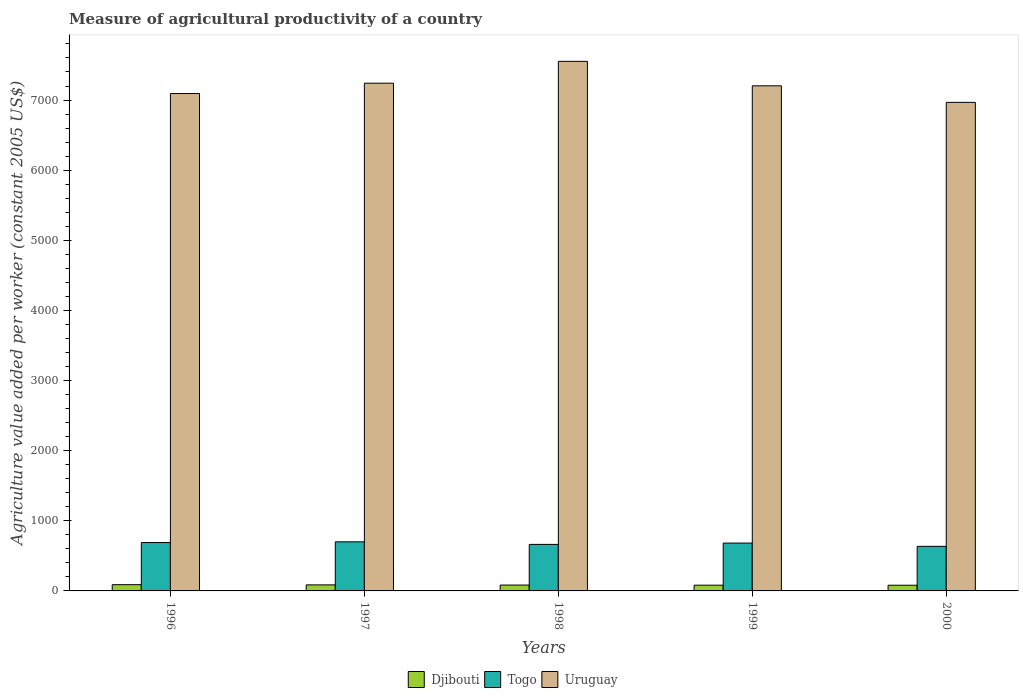How many groups of bars are there?
Offer a very short reply. 5. Are the number of bars per tick equal to the number of legend labels?
Offer a terse response. Yes. What is the measure of agricultural productivity in Togo in 1998?
Give a very brief answer. 663.32. Across all years, what is the maximum measure of agricultural productivity in Togo?
Make the answer very short. 700.08. Across all years, what is the minimum measure of agricultural productivity in Djibouti?
Offer a very short reply. 81.3. In which year was the measure of agricultural productivity in Djibouti maximum?
Your answer should be compact. 1996. In which year was the measure of agricultural productivity in Uruguay minimum?
Your answer should be very brief. 2000. What is the total measure of agricultural productivity in Togo in the graph?
Make the answer very short. 3371.1. What is the difference between the measure of agricultural productivity in Djibouti in 1999 and that in 2000?
Offer a very short reply. 0.63. What is the difference between the measure of agricultural productivity in Uruguay in 2000 and the measure of agricultural productivity in Togo in 1997?
Your answer should be compact. 6266.63. What is the average measure of agricultural productivity in Togo per year?
Keep it short and to the point. 674.22. In the year 2000, what is the difference between the measure of agricultural productivity in Togo and measure of agricultural productivity in Djibouti?
Offer a terse response. 554.53. What is the ratio of the measure of agricultural productivity in Uruguay in 1996 to that in 1998?
Your answer should be compact. 0.94. Is the difference between the measure of agricultural productivity in Togo in 1998 and 1999 greater than the difference between the measure of agricultural productivity in Djibouti in 1998 and 1999?
Provide a succinct answer. No. What is the difference between the highest and the second highest measure of agricultural productivity in Uruguay?
Keep it short and to the point. 311.42. What is the difference between the highest and the lowest measure of agricultural productivity in Djibouti?
Your response must be concise. 7.74. What does the 2nd bar from the left in 1997 represents?
Your answer should be very brief. Togo. What does the 2nd bar from the right in 1996 represents?
Your answer should be very brief. Togo. Is it the case that in every year, the sum of the measure of agricultural productivity in Uruguay and measure of agricultural productivity in Togo is greater than the measure of agricultural productivity in Djibouti?
Make the answer very short. Yes. How many years are there in the graph?
Give a very brief answer. 5. Are the values on the major ticks of Y-axis written in scientific E-notation?
Provide a succinct answer. No. Does the graph contain any zero values?
Offer a very short reply. No. How many legend labels are there?
Provide a succinct answer. 3. How are the legend labels stacked?
Keep it short and to the point. Horizontal. What is the title of the graph?
Ensure brevity in your answer.  Measure of agricultural productivity of a country. What is the label or title of the X-axis?
Provide a short and direct response. Years. What is the label or title of the Y-axis?
Provide a succinct answer. Agriculture value added per worker (constant 2005 US$). What is the Agriculture value added per worker (constant 2005 US$) in Djibouti in 1996?
Your answer should be very brief. 89.04. What is the Agriculture value added per worker (constant 2005 US$) in Togo in 1996?
Offer a terse response. 689.62. What is the Agriculture value added per worker (constant 2005 US$) in Uruguay in 1996?
Offer a very short reply. 7092.6. What is the Agriculture value added per worker (constant 2005 US$) in Djibouti in 1997?
Your answer should be very brief. 86.22. What is the Agriculture value added per worker (constant 2005 US$) of Togo in 1997?
Ensure brevity in your answer.  700.08. What is the Agriculture value added per worker (constant 2005 US$) in Uruguay in 1997?
Your answer should be compact. 7240.05. What is the Agriculture value added per worker (constant 2005 US$) in Djibouti in 1998?
Keep it short and to the point. 83.72. What is the Agriculture value added per worker (constant 2005 US$) of Togo in 1998?
Make the answer very short. 663.32. What is the Agriculture value added per worker (constant 2005 US$) of Uruguay in 1998?
Provide a succinct answer. 7551.47. What is the Agriculture value added per worker (constant 2005 US$) of Djibouti in 1999?
Give a very brief answer. 81.93. What is the Agriculture value added per worker (constant 2005 US$) of Togo in 1999?
Keep it short and to the point. 682.25. What is the Agriculture value added per worker (constant 2005 US$) of Uruguay in 1999?
Your answer should be compact. 7202.62. What is the Agriculture value added per worker (constant 2005 US$) in Djibouti in 2000?
Offer a terse response. 81.3. What is the Agriculture value added per worker (constant 2005 US$) of Togo in 2000?
Provide a succinct answer. 635.84. What is the Agriculture value added per worker (constant 2005 US$) of Uruguay in 2000?
Your answer should be very brief. 6966.71. Across all years, what is the maximum Agriculture value added per worker (constant 2005 US$) in Djibouti?
Offer a terse response. 89.04. Across all years, what is the maximum Agriculture value added per worker (constant 2005 US$) of Togo?
Provide a short and direct response. 700.08. Across all years, what is the maximum Agriculture value added per worker (constant 2005 US$) of Uruguay?
Make the answer very short. 7551.47. Across all years, what is the minimum Agriculture value added per worker (constant 2005 US$) in Djibouti?
Provide a short and direct response. 81.3. Across all years, what is the minimum Agriculture value added per worker (constant 2005 US$) in Togo?
Offer a very short reply. 635.84. Across all years, what is the minimum Agriculture value added per worker (constant 2005 US$) of Uruguay?
Provide a succinct answer. 6966.71. What is the total Agriculture value added per worker (constant 2005 US$) of Djibouti in the graph?
Make the answer very short. 422.21. What is the total Agriculture value added per worker (constant 2005 US$) of Togo in the graph?
Provide a short and direct response. 3371.1. What is the total Agriculture value added per worker (constant 2005 US$) of Uruguay in the graph?
Keep it short and to the point. 3.61e+04. What is the difference between the Agriculture value added per worker (constant 2005 US$) of Djibouti in 1996 and that in 1997?
Your answer should be compact. 2.82. What is the difference between the Agriculture value added per worker (constant 2005 US$) in Togo in 1996 and that in 1997?
Your answer should be compact. -10.46. What is the difference between the Agriculture value added per worker (constant 2005 US$) of Uruguay in 1996 and that in 1997?
Give a very brief answer. -147.45. What is the difference between the Agriculture value added per worker (constant 2005 US$) of Djibouti in 1996 and that in 1998?
Offer a terse response. 5.32. What is the difference between the Agriculture value added per worker (constant 2005 US$) of Togo in 1996 and that in 1998?
Offer a very short reply. 26.29. What is the difference between the Agriculture value added per worker (constant 2005 US$) of Uruguay in 1996 and that in 1998?
Ensure brevity in your answer.  -458.87. What is the difference between the Agriculture value added per worker (constant 2005 US$) of Djibouti in 1996 and that in 1999?
Offer a terse response. 7.11. What is the difference between the Agriculture value added per worker (constant 2005 US$) in Togo in 1996 and that in 1999?
Make the answer very short. 7.37. What is the difference between the Agriculture value added per worker (constant 2005 US$) in Uruguay in 1996 and that in 1999?
Offer a very short reply. -110.02. What is the difference between the Agriculture value added per worker (constant 2005 US$) in Djibouti in 1996 and that in 2000?
Provide a succinct answer. 7.74. What is the difference between the Agriculture value added per worker (constant 2005 US$) in Togo in 1996 and that in 2000?
Keep it short and to the point. 53.78. What is the difference between the Agriculture value added per worker (constant 2005 US$) of Uruguay in 1996 and that in 2000?
Offer a terse response. 125.89. What is the difference between the Agriculture value added per worker (constant 2005 US$) in Djibouti in 1997 and that in 1998?
Your answer should be very brief. 2.49. What is the difference between the Agriculture value added per worker (constant 2005 US$) in Togo in 1997 and that in 1998?
Give a very brief answer. 36.75. What is the difference between the Agriculture value added per worker (constant 2005 US$) of Uruguay in 1997 and that in 1998?
Ensure brevity in your answer.  -311.42. What is the difference between the Agriculture value added per worker (constant 2005 US$) of Djibouti in 1997 and that in 1999?
Keep it short and to the point. 4.29. What is the difference between the Agriculture value added per worker (constant 2005 US$) in Togo in 1997 and that in 1999?
Your response must be concise. 17.83. What is the difference between the Agriculture value added per worker (constant 2005 US$) of Uruguay in 1997 and that in 1999?
Provide a short and direct response. 37.42. What is the difference between the Agriculture value added per worker (constant 2005 US$) in Djibouti in 1997 and that in 2000?
Ensure brevity in your answer.  4.91. What is the difference between the Agriculture value added per worker (constant 2005 US$) in Togo in 1997 and that in 2000?
Offer a terse response. 64.24. What is the difference between the Agriculture value added per worker (constant 2005 US$) in Uruguay in 1997 and that in 2000?
Your answer should be compact. 273.34. What is the difference between the Agriculture value added per worker (constant 2005 US$) of Djibouti in 1998 and that in 1999?
Ensure brevity in your answer.  1.79. What is the difference between the Agriculture value added per worker (constant 2005 US$) of Togo in 1998 and that in 1999?
Offer a very short reply. -18.92. What is the difference between the Agriculture value added per worker (constant 2005 US$) in Uruguay in 1998 and that in 1999?
Provide a succinct answer. 348.85. What is the difference between the Agriculture value added per worker (constant 2005 US$) of Djibouti in 1998 and that in 2000?
Provide a short and direct response. 2.42. What is the difference between the Agriculture value added per worker (constant 2005 US$) in Togo in 1998 and that in 2000?
Provide a short and direct response. 27.49. What is the difference between the Agriculture value added per worker (constant 2005 US$) of Uruguay in 1998 and that in 2000?
Your answer should be compact. 584.76. What is the difference between the Agriculture value added per worker (constant 2005 US$) of Djibouti in 1999 and that in 2000?
Give a very brief answer. 0.63. What is the difference between the Agriculture value added per worker (constant 2005 US$) in Togo in 1999 and that in 2000?
Keep it short and to the point. 46.41. What is the difference between the Agriculture value added per worker (constant 2005 US$) in Uruguay in 1999 and that in 2000?
Give a very brief answer. 235.91. What is the difference between the Agriculture value added per worker (constant 2005 US$) of Djibouti in 1996 and the Agriculture value added per worker (constant 2005 US$) of Togo in 1997?
Ensure brevity in your answer.  -611.04. What is the difference between the Agriculture value added per worker (constant 2005 US$) in Djibouti in 1996 and the Agriculture value added per worker (constant 2005 US$) in Uruguay in 1997?
Keep it short and to the point. -7151.01. What is the difference between the Agriculture value added per worker (constant 2005 US$) of Togo in 1996 and the Agriculture value added per worker (constant 2005 US$) of Uruguay in 1997?
Keep it short and to the point. -6550.43. What is the difference between the Agriculture value added per worker (constant 2005 US$) of Djibouti in 1996 and the Agriculture value added per worker (constant 2005 US$) of Togo in 1998?
Give a very brief answer. -574.29. What is the difference between the Agriculture value added per worker (constant 2005 US$) of Djibouti in 1996 and the Agriculture value added per worker (constant 2005 US$) of Uruguay in 1998?
Provide a short and direct response. -7462.43. What is the difference between the Agriculture value added per worker (constant 2005 US$) in Togo in 1996 and the Agriculture value added per worker (constant 2005 US$) in Uruguay in 1998?
Give a very brief answer. -6861.85. What is the difference between the Agriculture value added per worker (constant 2005 US$) in Djibouti in 1996 and the Agriculture value added per worker (constant 2005 US$) in Togo in 1999?
Your answer should be very brief. -593.21. What is the difference between the Agriculture value added per worker (constant 2005 US$) in Djibouti in 1996 and the Agriculture value added per worker (constant 2005 US$) in Uruguay in 1999?
Offer a very short reply. -7113.58. What is the difference between the Agriculture value added per worker (constant 2005 US$) in Togo in 1996 and the Agriculture value added per worker (constant 2005 US$) in Uruguay in 1999?
Provide a succinct answer. -6513. What is the difference between the Agriculture value added per worker (constant 2005 US$) in Djibouti in 1996 and the Agriculture value added per worker (constant 2005 US$) in Togo in 2000?
Offer a very short reply. -546.8. What is the difference between the Agriculture value added per worker (constant 2005 US$) of Djibouti in 1996 and the Agriculture value added per worker (constant 2005 US$) of Uruguay in 2000?
Keep it short and to the point. -6877.67. What is the difference between the Agriculture value added per worker (constant 2005 US$) of Togo in 1996 and the Agriculture value added per worker (constant 2005 US$) of Uruguay in 2000?
Your response must be concise. -6277.09. What is the difference between the Agriculture value added per worker (constant 2005 US$) in Djibouti in 1997 and the Agriculture value added per worker (constant 2005 US$) in Togo in 1998?
Give a very brief answer. -577.11. What is the difference between the Agriculture value added per worker (constant 2005 US$) of Djibouti in 1997 and the Agriculture value added per worker (constant 2005 US$) of Uruguay in 1998?
Provide a succinct answer. -7465.25. What is the difference between the Agriculture value added per worker (constant 2005 US$) of Togo in 1997 and the Agriculture value added per worker (constant 2005 US$) of Uruguay in 1998?
Ensure brevity in your answer.  -6851.39. What is the difference between the Agriculture value added per worker (constant 2005 US$) in Djibouti in 1997 and the Agriculture value added per worker (constant 2005 US$) in Togo in 1999?
Provide a succinct answer. -596.03. What is the difference between the Agriculture value added per worker (constant 2005 US$) in Djibouti in 1997 and the Agriculture value added per worker (constant 2005 US$) in Uruguay in 1999?
Ensure brevity in your answer.  -7116.4. What is the difference between the Agriculture value added per worker (constant 2005 US$) in Togo in 1997 and the Agriculture value added per worker (constant 2005 US$) in Uruguay in 1999?
Your response must be concise. -6502.55. What is the difference between the Agriculture value added per worker (constant 2005 US$) of Djibouti in 1997 and the Agriculture value added per worker (constant 2005 US$) of Togo in 2000?
Make the answer very short. -549.62. What is the difference between the Agriculture value added per worker (constant 2005 US$) in Djibouti in 1997 and the Agriculture value added per worker (constant 2005 US$) in Uruguay in 2000?
Your answer should be compact. -6880.49. What is the difference between the Agriculture value added per worker (constant 2005 US$) of Togo in 1997 and the Agriculture value added per worker (constant 2005 US$) of Uruguay in 2000?
Give a very brief answer. -6266.63. What is the difference between the Agriculture value added per worker (constant 2005 US$) of Djibouti in 1998 and the Agriculture value added per worker (constant 2005 US$) of Togo in 1999?
Offer a terse response. -598.52. What is the difference between the Agriculture value added per worker (constant 2005 US$) in Djibouti in 1998 and the Agriculture value added per worker (constant 2005 US$) in Uruguay in 1999?
Keep it short and to the point. -7118.9. What is the difference between the Agriculture value added per worker (constant 2005 US$) in Togo in 1998 and the Agriculture value added per worker (constant 2005 US$) in Uruguay in 1999?
Provide a succinct answer. -6539.3. What is the difference between the Agriculture value added per worker (constant 2005 US$) in Djibouti in 1998 and the Agriculture value added per worker (constant 2005 US$) in Togo in 2000?
Provide a short and direct response. -552.11. What is the difference between the Agriculture value added per worker (constant 2005 US$) of Djibouti in 1998 and the Agriculture value added per worker (constant 2005 US$) of Uruguay in 2000?
Give a very brief answer. -6882.99. What is the difference between the Agriculture value added per worker (constant 2005 US$) of Togo in 1998 and the Agriculture value added per worker (constant 2005 US$) of Uruguay in 2000?
Offer a terse response. -6303.39. What is the difference between the Agriculture value added per worker (constant 2005 US$) of Djibouti in 1999 and the Agriculture value added per worker (constant 2005 US$) of Togo in 2000?
Provide a short and direct response. -553.91. What is the difference between the Agriculture value added per worker (constant 2005 US$) of Djibouti in 1999 and the Agriculture value added per worker (constant 2005 US$) of Uruguay in 2000?
Your answer should be compact. -6884.78. What is the difference between the Agriculture value added per worker (constant 2005 US$) of Togo in 1999 and the Agriculture value added per worker (constant 2005 US$) of Uruguay in 2000?
Your answer should be very brief. -6284.46. What is the average Agriculture value added per worker (constant 2005 US$) of Djibouti per year?
Make the answer very short. 84.44. What is the average Agriculture value added per worker (constant 2005 US$) of Togo per year?
Your answer should be very brief. 674.22. What is the average Agriculture value added per worker (constant 2005 US$) in Uruguay per year?
Give a very brief answer. 7210.69. In the year 1996, what is the difference between the Agriculture value added per worker (constant 2005 US$) of Djibouti and Agriculture value added per worker (constant 2005 US$) of Togo?
Provide a succinct answer. -600.58. In the year 1996, what is the difference between the Agriculture value added per worker (constant 2005 US$) of Djibouti and Agriculture value added per worker (constant 2005 US$) of Uruguay?
Provide a succinct answer. -7003.56. In the year 1996, what is the difference between the Agriculture value added per worker (constant 2005 US$) of Togo and Agriculture value added per worker (constant 2005 US$) of Uruguay?
Offer a very short reply. -6402.98. In the year 1997, what is the difference between the Agriculture value added per worker (constant 2005 US$) of Djibouti and Agriculture value added per worker (constant 2005 US$) of Togo?
Ensure brevity in your answer.  -613.86. In the year 1997, what is the difference between the Agriculture value added per worker (constant 2005 US$) of Djibouti and Agriculture value added per worker (constant 2005 US$) of Uruguay?
Offer a terse response. -7153.83. In the year 1997, what is the difference between the Agriculture value added per worker (constant 2005 US$) in Togo and Agriculture value added per worker (constant 2005 US$) in Uruguay?
Your response must be concise. -6539.97. In the year 1998, what is the difference between the Agriculture value added per worker (constant 2005 US$) in Djibouti and Agriculture value added per worker (constant 2005 US$) in Togo?
Provide a succinct answer. -579.6. In the year 1998, what is the difference between the Agriculture value added per worker (constant 2005 US$) in Djibouti and Agriculture value added per worker (constant 2005 US$) in Uruguay?
Offer a terse response. -7467.75. In the year 1998, what is the difference between the Agriculture value added per worker (constant 2005 US$) of Togo and Agriculture value added per worker (constant 2005 US$) of Uruguay?
Ensure brevity in your answer.  -6888.15. In the year 1999, what is the difference between the Agriculture value added per worker (constant 2005 US$) of Djibouti and Agriculture value added per worker (constant 2005 US$) of Togo?
Keep it short and to the point. -600.32. In the year 1999, what is the difference between the Agriculture value added per worker (constant 2005 US$) in Djibouti and Agriculture value added per worker (constant 2005 US$) in Uruguay?
Offer a terse response. -7120.69. In the year 1999, what is the difference between the Agriculture value added per worker (constant 2005 US$) in Togo and Agriculture value added per worker (constant 2005 US$) in Uruguay?
Ensure brevity in your answer.  -6520.38. In the year 2000, what is the difference between the Agriculture value added per worker (constant 2005 US$) in Djibouti and Agriculture value added per worker (constant 2005 US$) in Togo?
Make the answer very short. -554.53. In the year 2000, what is the difference between the Agriculture value added per worker (constant 2005 US$) of Djibouti and Agriculture value added per worker (constant 2005 US$) of Uruguay?
Ensure brevity in your answer.  -6885.41. In the year 2000, what is the difference between the Agriculture value added per worker (constant 2005 US$) of Togo and Agriculture value added per worker (constant 2005 US$) of Uruguay?
Offer a very short reply. -6330.87. What is the ratio of the Agriculture value added per worker (constant 2005 US$) of Djibouti in 1996 to that in 1997?
Make the answer very short. 1.03. What is the ratio of the Agriculture value added per worker (constant 2005 US$) in Togo in 1996 to that in 1997?
Keep it short and to the point. 0.99. What is the ratio of the Agriculture value added per worker (constant 2005 US$) in Uruguay in 1996 to that in 1997?
Your answer should be very brief. 0.98. What is the ratio of the Agriculture value added per worker (constant 2005 US$) in Djibouti in 1996 to that in 1998?
Keep it short and to the point. 1.06. What is the ratio of the Agriculture value added per worker (constant 2005 US$) of Togo in 1996 to that in 1998?
Make the answer very short. 1.04. What is the ratio of the Agriculture value added per worker (constant 2005 US$) of Uruguay in 1996 to that in 1998?
Offer a very short reply. 0.94. What is the ratio of the Agriculture value added per worker (constant 2005 US$) of Djibouti in 1996 to that in 1999?
Your answer should be compact. 1.09. What is the ratio of the Agriculture value added per worker (constant 2005 US$) in Togo in 1996 to that in 1999?
Give a very brief answer. 1.01. What is the ratio of the Agriculture value added per worker (constant 2005 US$) of Uruguay in 1996 to that in 1999?
Your answer should be compact. 0.98. What is the ratio of the Agriculture value added per worker (constant 2005 US$) of Djibouti in 1996 to that in 2000?
Your answer should be very brief. 1.1. What is the ratio of the Agriculture value added per worker (constant 2005 US$) in Togo in 1996 to that in 2000?
Provide a succinct answer. 1.08. What is the ratio of the Agriculture value added per worker (constant 2005 US$) of Uruguay in 1996 to that in 2000?
Ensure brevity in your answer.  1.02. What is the ratio of the Agriculture value added per worker (constant 2005 US$) in Djibouti in 1997 to that in 1998?
Keep it short and to the point. 1.03. What is the ratio of the Agriculture value added per worker (constant 2005 US$) in Togo in 1997 to that in 1998?
Offer a terse response. 1.06. What is the ratio of the Agriculture value added per worker (constant 2005 US$) of Uruguay in 1997 to that in 1998?
Your answer should be very brief. 0.96. What is the ratio of the Agriculture value added per worker (constant 2005 US$) in Djibouti in 1997 to that in 1999?
Your response must be concise. 1.05. What is the ratio of the Agriculture value added per worker (constant 2005 US$) of Togo in 1997 to that in 1999?
Provide a short and direct response. 1.03. What is the ratio of the Agriculture value added per worker (constant 2005 US$) of Djibouti in 1997 to that in 2000?
Provide a short and direct response. 1.06. What is the ratio of the Agriculture value added per worker (constant 2005 US$) in Togo in 1997 to that in 2000?
Offer a terse response. 1.1. What is the ratio of the Agriculture value added per worker (constant 2005 US$) of Uruguay in 1997 to that in 2000?
Give a very brief answer. 1.04. What is the ratio of the Agriculture value added per worker (constant 2005 US$) of Djibouti in 1998 to that in 1999?
Provide a succinct answer. 1.02. What is the ratio of the Agriculture value added per worker (constant 2005 US$) of Togo in 1998 to that in 1999?
Provide a short and direct response. 0.97. What is the ratio of the Agriculture value added per worker (constant 2005 US$) in Uruguay in 1998 to that in 1999?
Offer a terse response. 1.05. What is the ratio of the Agriculture value added per worker (constant 2005 US$) of Djibouti in 1998 to that in 2000?
Give a very brief answer. 1.03. What is the ratio of the Agriculture value added per worker (constant 2005 US$) in Togo in 1998 to that in 2000?
Offer a terse response. 1.04. What is the ratio of the Agriculture value added per worker (constant 2005 US$) of Uruguay in 1998 to that in 2000?
Give a very brief answer. 1.08. What is the ratio of the Agriculture value added per worker (constant 2005 US$) in Djibouti in 1999 to that in 2000?
Offer a very short reply. 1.01. What is the ratio of the Agriculture value added per worker (constant 2005 US$) in Togo in 1999 to that in 2000?
Your answer should be very brief. 1.07. What is the ratio of the Agriculture value added per worker (constant 2005 US$) in Uruguay in 1999 to that in 2000?
Give a very brief answer. 1.03. What is the difference between the highest and the second highest Agriculture value added per worker (constant 2005 US$) of Djibouti?
Provide a succinct answer. 2.82. What is the difference between the highest and the second highest Agriculture value added per worker (constant 2005 US$) of Togo?
Offer a terse response. 10.46. What is the difference between the highest and the second highest Agriculture value added per worker (constant 2005 US$) in Uruguay?
Ensure brevity in your answer.  311.42. What is the difference between the highest and the lowest Agriculture value added per worker (constant 2005 US$) of Djibouti?
Offer a very short reply. 7.74. What is the difference between the highest and the lowest Agriculture value added per worker (constant 2005 US$) in Togo?
Make the answer very short. 64.24. What is the difference between the highest and the lowest Agriculture value added per worker (constant 2005 US$) in Uruguay?
Offer a very short reply. 584.76. 